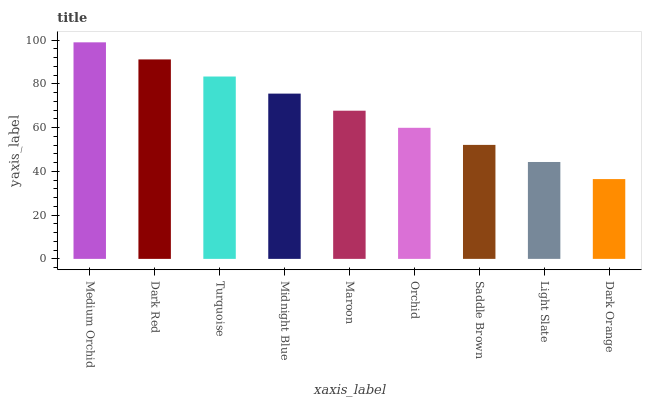Is Dark Red the minimum?
Answer yes or no. No. Is Dark Red the maximum?
Answer yes or no. No. Is Medium Orchid greater than Dark Red?
Answer yes or no. Yes. Is Dark Red less than Medium Orchid?
Answer yes or no. Yes. Is Dark Red greater than Medium Orchid?
Answer yes or no. No. Is Medium Orchid less than Dark Red?
Answer yes or no. No. Is Maroon the high median?
Answer yes or no. Yes. Is Maroon the low median?
Answer yes or no. Yes. Is Light Slate the high median?
Answer yes or no. No. Is Medium Orchid the low median?
Answer yes or no. No. 